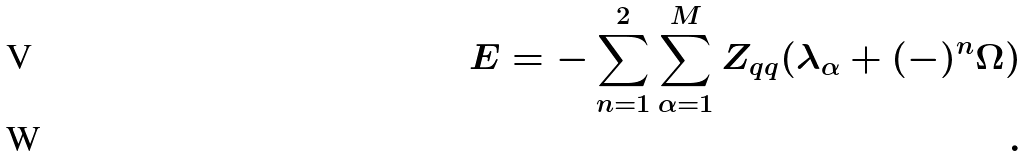Convert formula to latex. <formula><loc_0><loc_0><loc_500><loc_500>E = - \sum _ { n = 1 } ^ { 2 } \sum _ { \alpha = 1 } ^ { M } Z _ { q q } ( \lambda _ { \alpha } + ( - ) ^ { n } \Omega ) \\ .</formula> 